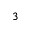<formula> <loc_0><loc_0><loc_500><loc_500>^ { 3 }</formula> 